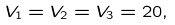Convert formula to latex. <formula><loc_0><loc_0><loc_500><loc_500>V _ { 1 } = V _ { 2 } = V _ { 3 } = 2 0 ,</formula> 